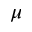<formula> <loc_0><loc_0><loc_500><loc_500>\mu</formula> 